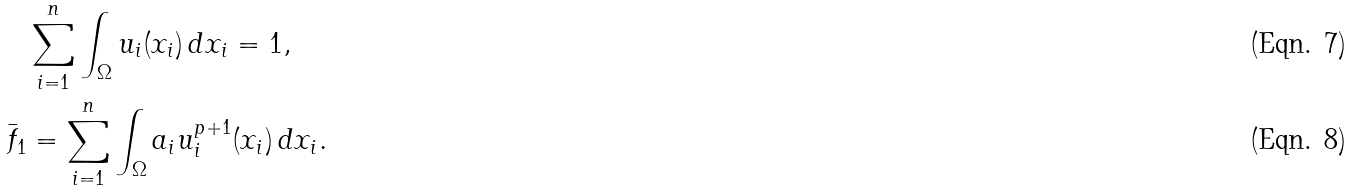<formula> <loc_0><loc_0><loc_500><loc_500>& \sum _ { i = 1 } ^ { n } \int _ { \Omega } u _ { i } ( x _ { i } ) \, d x _ { i } = 1 , \\ \bar { f } _ { 1 } & = \sum _ { i = 1 } ^ { n } \int _ { \Omega } a _ { i } u _ { i } ^ { p + 1 } ( x _ { i } ) \, d x _ { i } .</formula> 